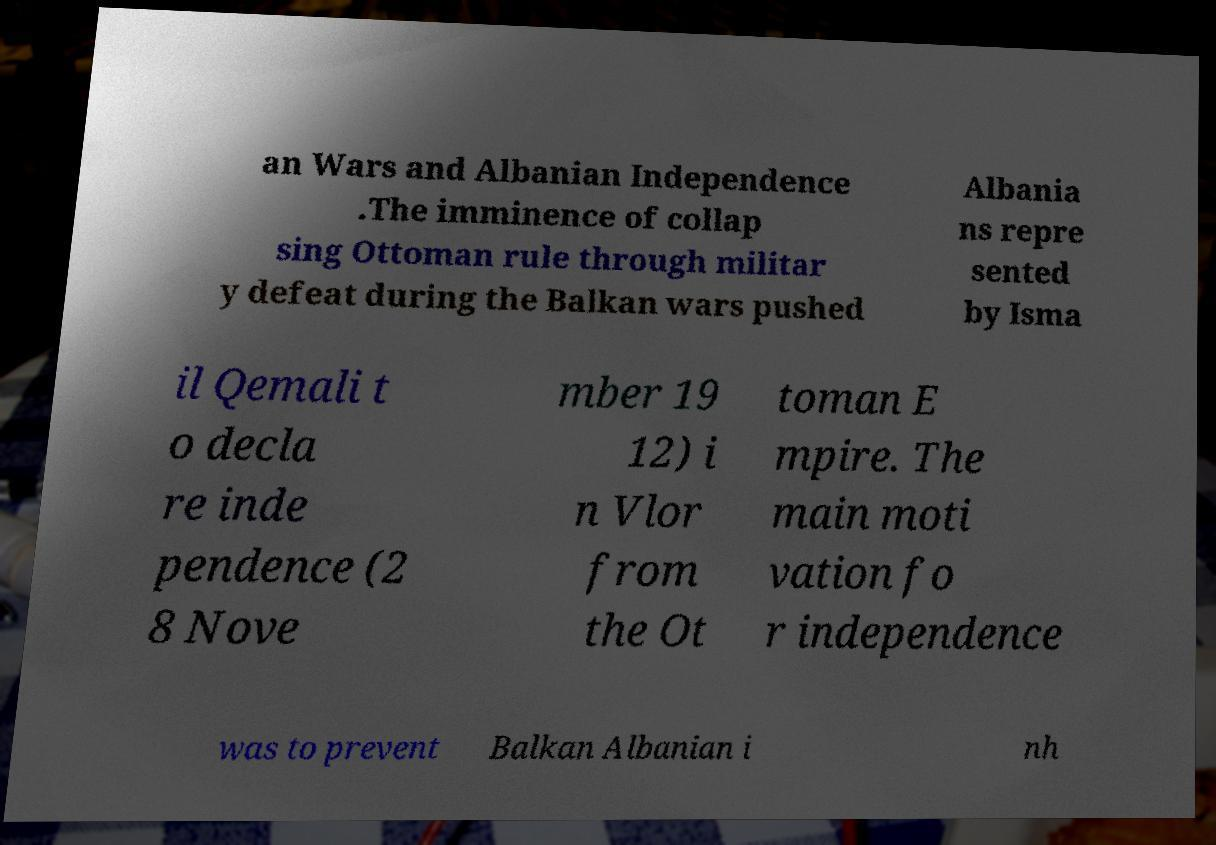For documentation purposes, I need the text within this image transcribed. Could you provide that? an Wars and Albanian Independence .The imminence of collap sing Ottoman rule through militar y defeat during the Balkan wars pushed Albania ns repre sented by Isma il Qemali t o decla re inde pendence (2 8 Nove mber 19 12) i n Vlor from the Ot toman E mpire. The main moti vation fo r independence was to prevent Balkan Albanian i nh 